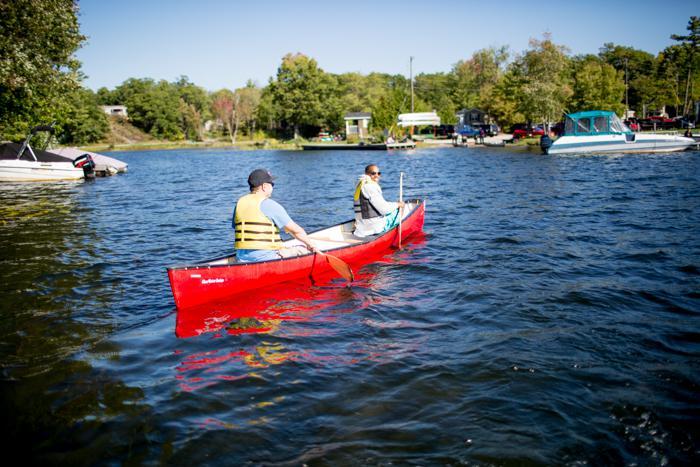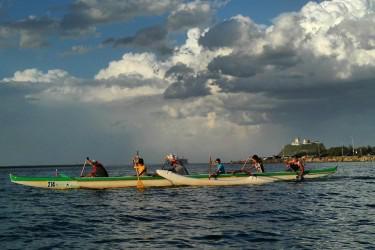The first image is the image on the left, the second image is the image on the right. For the images displayed, is the sentence "An image shows just one bright yellow watercraft with riders." factually correct? Answer yes or no. No. 